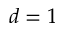<formula> <loc_0><loc_0><loc_500><loc_500>d = 1</formula> 